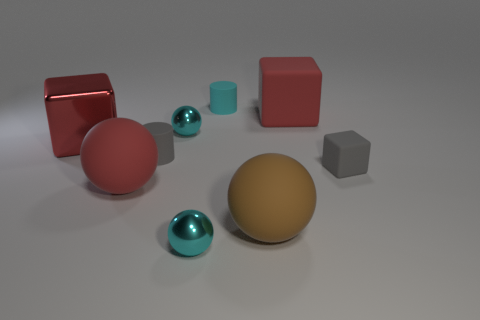Add 1 small metal balls. How many objects exist? 10 Subtract all cylinders. How many objects are left? 7 Subtract all large red metal blocks. Subtract all gray cubes. How many objects are left? 7 Add 8 big metal blocks. How many big metal blocks are left? 9 Add 3 yellow matte things. How many yellow matte things exist? 3 Subtract 0 green balls. How many objects are left? 9 